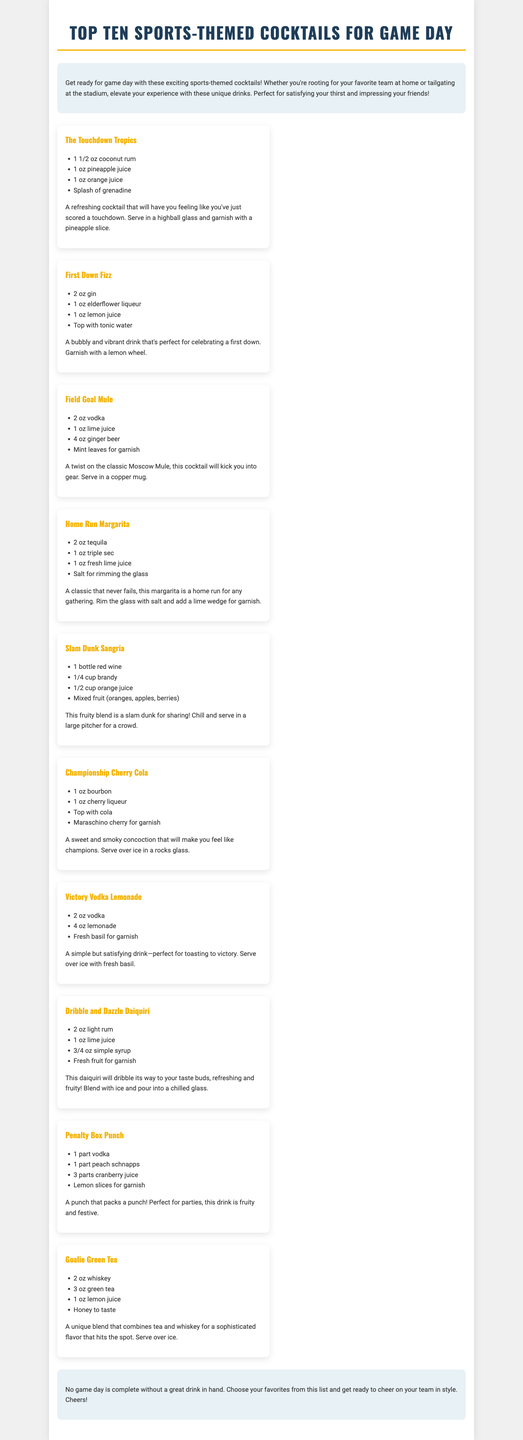what is the title of the brochure? The title is prominently displayed at the top of the document.
Answer: Top Ten Sports-Themed Cocktails for Game Day how many cocktails are listed in the brochure? The brochure presents a selection of ten cocktails, which is mentioned in the introduction.
Answer: Ten what is the main ingredient in the "Home Run Margarita"? The brochure lists specific ingredients for each cocktail, including this one.
Answer: Tequila which cocktail is described as a "sweet and smoky concoction"? The description refers to a specific cocktail among the ten listed in the brochure.
Answer: Championship Cherry Cola what type of glass is the "Field Goal Mule" served in? The document specifies the type of glass used for each cocktail preparation.
Answer: Copper mug which cocktail includes mint leaves as a garnish? The document lists garnishes for each cocktail, making this information retrievable.
Answer: Field Goal Mule what is the primary color of the brochure's background? The document provides a consistent visual design, which can be identified from the overall layout.
Answer: White which cocktail is designed for sharing? The description indicates that this cocktail is meant to be enjoyed by multiple people.
Answer: Slam Dunk Sangria what garnish is suggested for the "Victory Vodka Lemonade"? The document specifies garnishes for each cocktail, including this one.
Answer: Fresh basil which cocktail features elderflower liqueur? The ingredients section provides detailed information about what goes into each cocktail.
Answer: First Down Fizz 